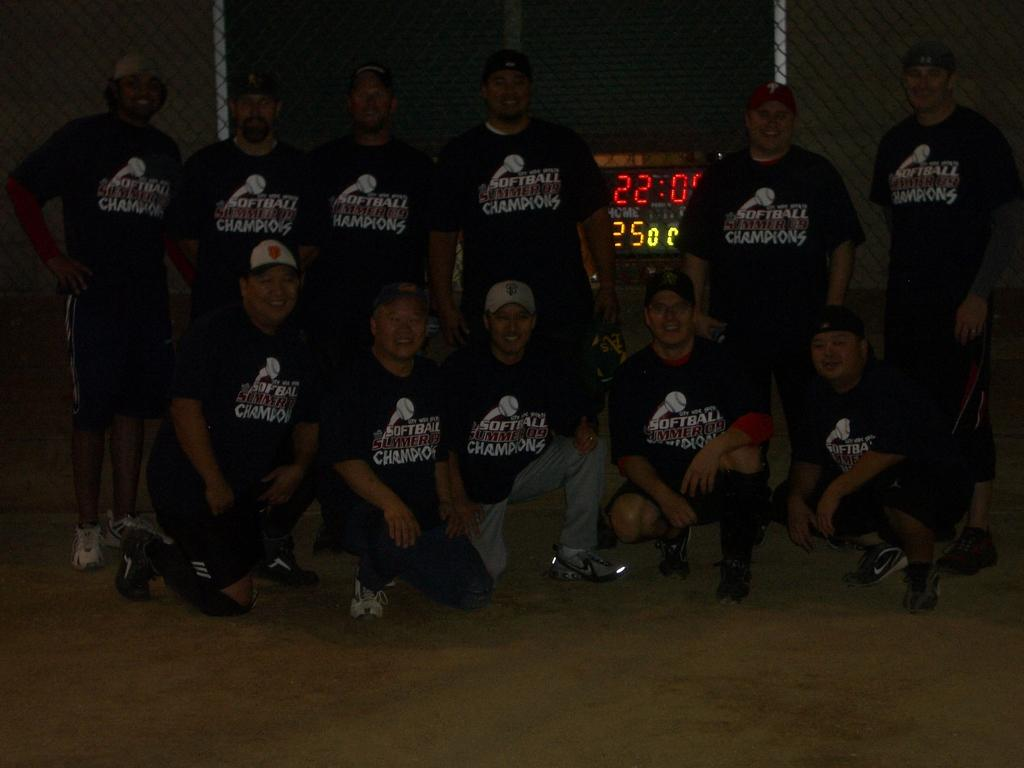<image>
Write a terse but informative summary of the picture. Several people wearing softball champions shirts are grouped together in a dark room. 